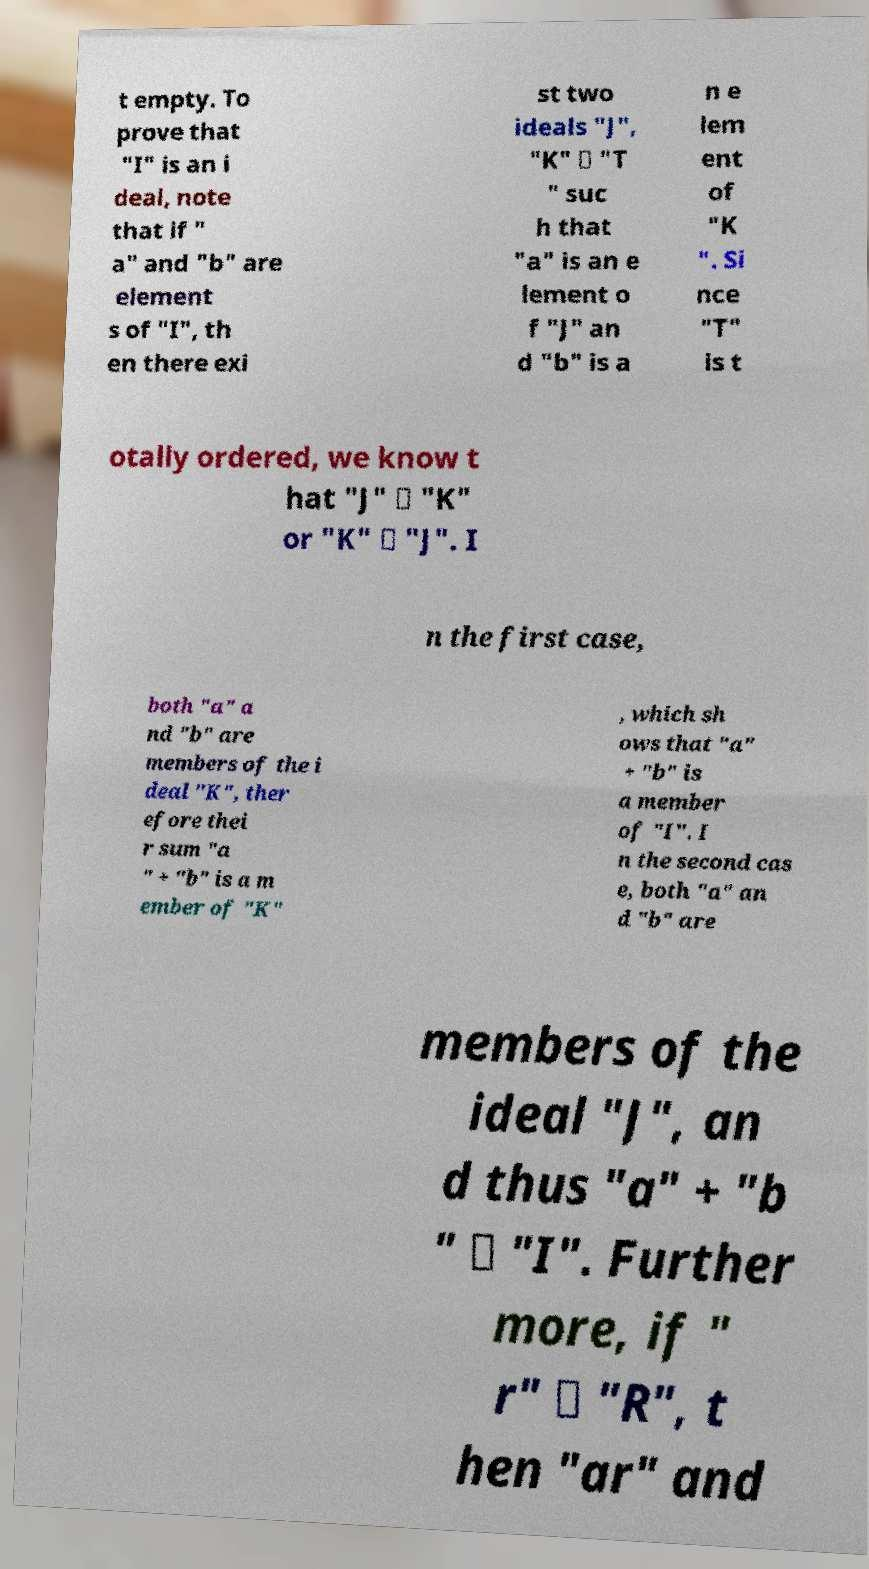Could you assist in decoding the text presented in this image and type it out clearly? t empty. To prove that "I" is an i deal, note that if " a" and "b" are element s of "I", th en there exi st two ideals "J", "K" ∈ "T " suc h that "a" is an e lement o f "J" an d "b" is a n e lem ent of "K ". Si nce "T" is t otally ordered, we know t hat "J" ⊆ "K" or "K" ⊆ "J". I n the first case, both "a" a nd "b" are members of the i deal "K", ther efore thei r sum "a " + "b" is a m ember of "K" , which sh ows that "a" + "b" is a member of "I". I n the second cas e, both "a" an d "b" are members of the ideal "J", an d thus "a" + "b " ∈ "I". Further more, if " r" ∈ "R", t hen "ar" and 